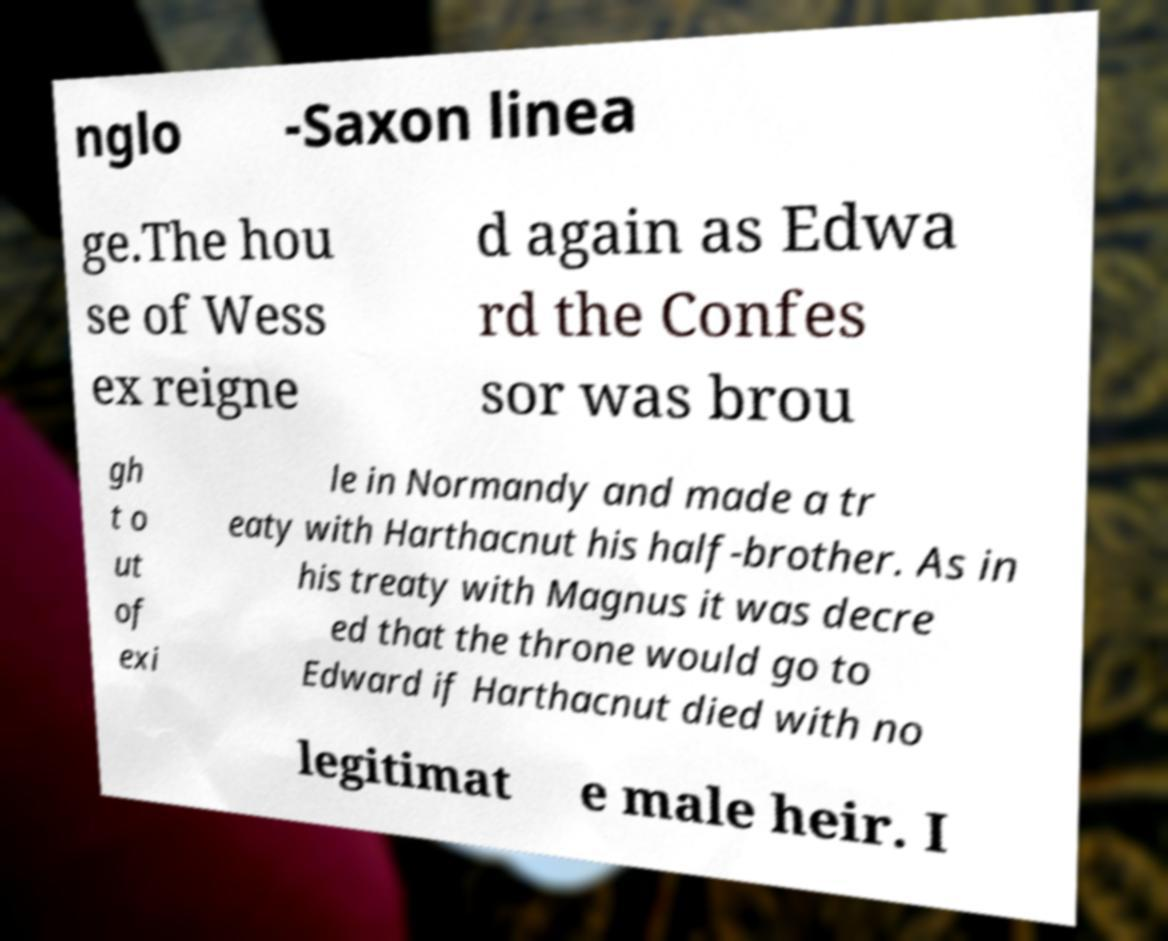For documentation purposes, I need the text within this image transcribed. Could you provide that? nglo -Saxon linea ge.The hou se of Wess ex reigne d again as Edwa rd the Confes sor was brou gh t o ut of exi le in Normandy and made a tr eaty with Harthacnut his half-brother. As in his treaty with Magnus it was decre ed that the throne would go to Edward if Harthacnut died with no legitimat e male heir. I 